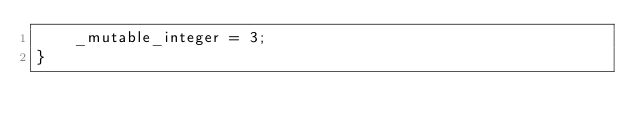<code> <loc_0><loc_0><loc_500><loc_500><_Rust_>    _mutable_integer = 3;
}
</code> 